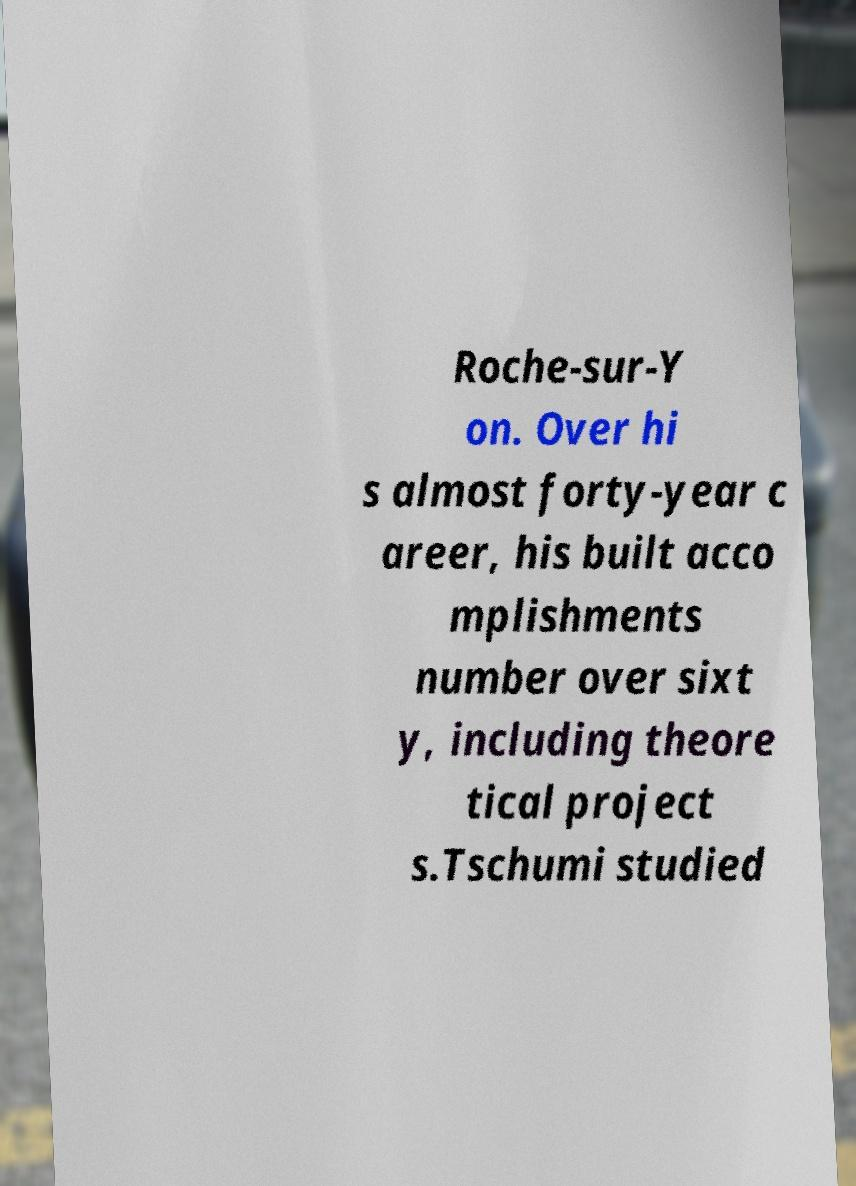Please read and relay the text visible in this image. What does it say? Roche-sur-Y on. Over hi s almost forty-year c areer, his built acco mplishments number over sixt y, including theore tical project s.Tschumi studied 